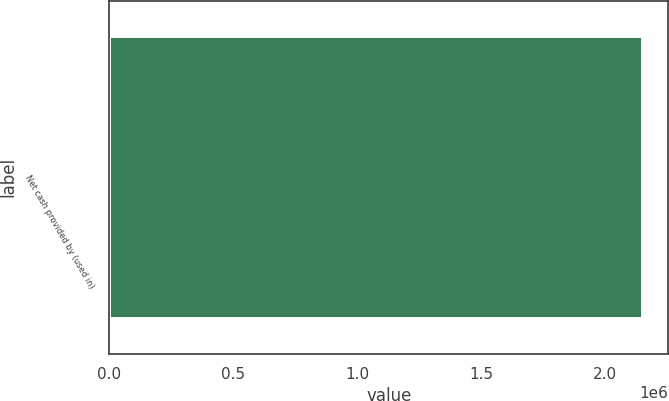<chart> <loc_0><loc_0><loc_500><loc_500><bar_chart><fcel>Net cash provided by (used in)<nl><fcel>2.14846e+06<nl></chart> 